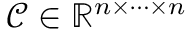Convert formula to latex. <formula><loc_0><loc_0><loc_500><loc_500>\mathcal { C } \in \mathbb { R } ^ { n \times \cdots \times n }</formula> 